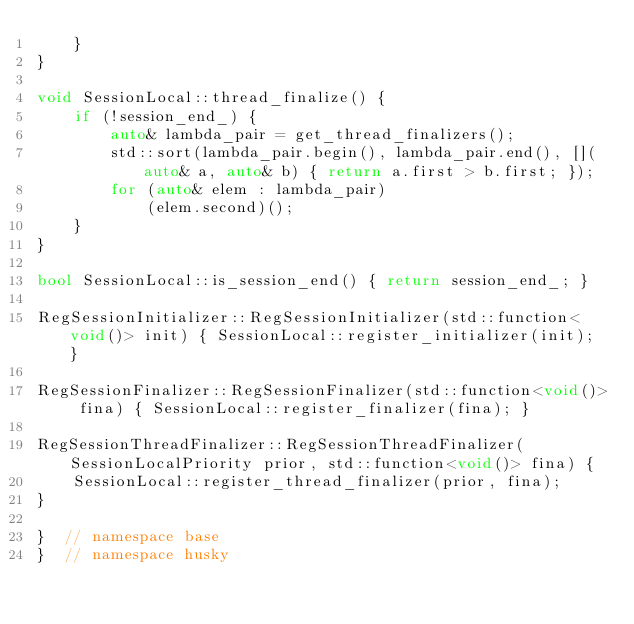<code> <loc_0><loc_0><loc_500><loc_500><_C++_>    }
}

void SessionLocal::thread_finalize() {
    if (!session_end_) {
        auto& lambda_pair = get_thread_finalizers();
        std::sort(lambda_pair.begin(), lambda_pair.end(), [](auto& a, auto& b) { return a.first > b.first; });
        for (auto& elem : lambda_pair)
            (elem.second)();
    }
}

bool SessionLocal::is_session_end() { return session_end_; }

RegSessionInitializer::RegSessionInitializer(std::function<void()> init) { SessionLocal::register_initializer(init); }

RegSessionFinalizer::RegSessionFinalizer(std::function<void()> fina) { SessionLocal::register_finalizer(fina); }

RegSessionThreadFinalizer::RegSessionThreadFinalizer(SessionLocalPriority prior, std::function<void()> fina) {
    SessionLocal::register_thread_finalizer(prior, fina);
}

}  // namespace base
}  // namespace husky
</code> 